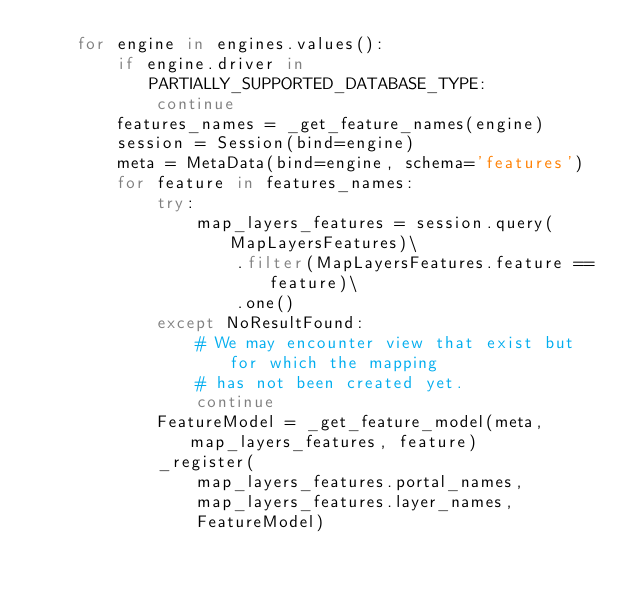<code> <loc_0><loc_0><loc_500><loc_500><_Python_>    for engine in engines.values():
        if engine.driver in PARTIALLY_SUPPORTED_DATABASE_TYPE:
            continue
        features_names = _get_feature_names(engine)
        session = Session(bind=engine)
        meta = MetaData(bind=engine, schema='features')
        for feature in features_names:
            try:
                map_layers_features = session.query(MapLayersFeatures)\
                    .filter(MapLayersFeatures.feature == feature)\
                    .one()
            except NoResultFound:
                # We may encounter view that exist but for which the mapping
                # has not been created yet.
                continue
            FeatureModel = _get_feature_model(meta, map_layers_features, feature)
            _register(
                map_layers_features.portal_names,
                map_layers_features.layer_names,
                FeatureModel)

</code> 